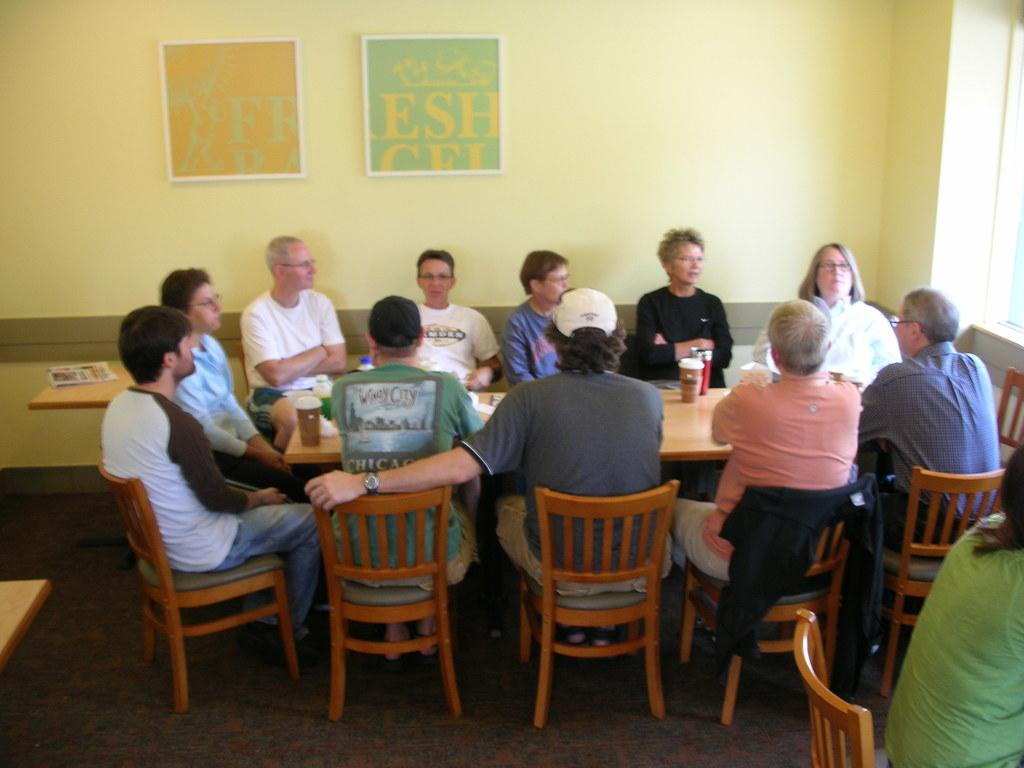How many people are in the image? There is a group of people in the image. What is on the table in the image? There is a paper and a bottle on the table in the image. What can be seen in the background of the image? The background of the image includes a poster and a wall. Are the sisters in the image engaged in a battle with the doll? There is no mention of sisters or a doll in the image, so this scenario cannot be confirmed or denied. 